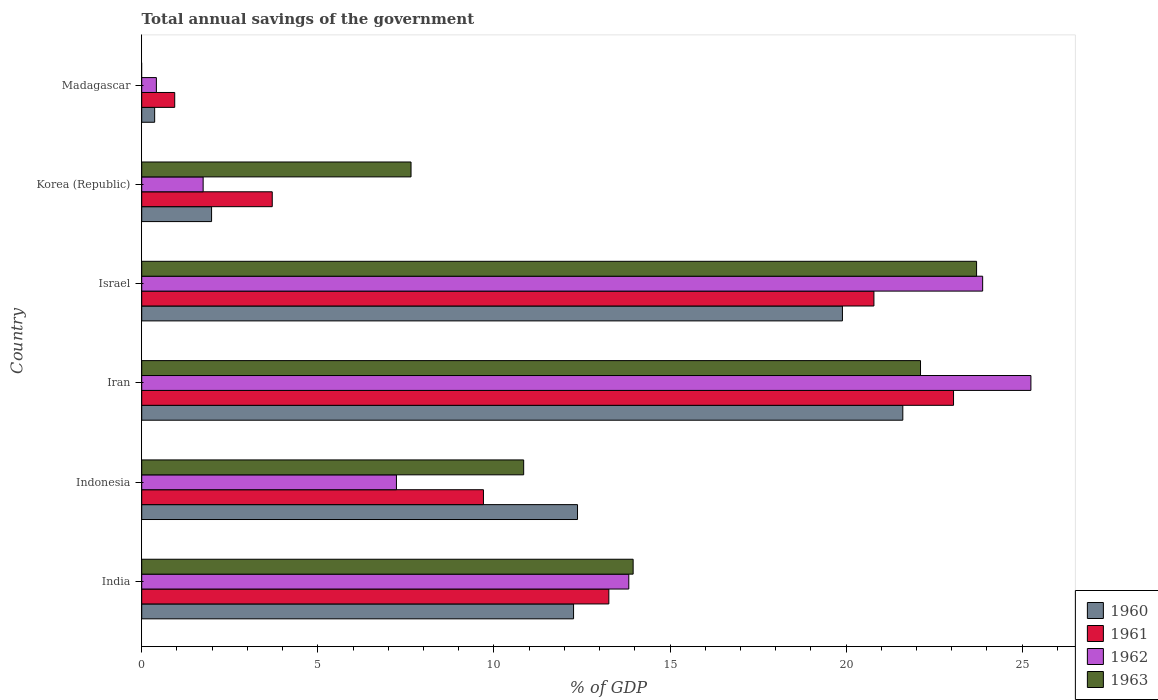How many different coloured bars are there?
Offer a very short reply. 4. How many groups of bars are there?
Your answer should be very brief. 6. Are the number of bars per tick equal to the number of legend labels?
Your answer should be very brief. No. Are the number of bars on each tick of the Y-axis equal?
Give a very brief answer. No. In how many cases, is the number of bars for a given country not equal to the number of legend labels?
Your response must be concise. 1. What is the total annual savings of the government in 1960 in Madagascar?
Make the answer very short. 0.37. Across all countries, what is the maximum total annual savings of the government in 1962?
Provide a succinct answer. 25.25. Across all countries, what is the minimum total annual savings of the government in 1960?
Provide a succinct answer. 0.37. In which country was the total annual savings of the government in 1962 maximum?
Your answer should be very brief. Iran. What is the total total annual savings of the government in 1963 in the graph?
Your response must be concise. 78.26. What is the difference between the total annual savings of the government in 1961 in Indonesia and that in Iran?
Offer a terse response. -13.35. What is the difference between the total annual savings of the government in 1963 in India and the total annual savings of the government in 1960 in Indonesia?
Provide a succinct answer. 1.58. What is the average total annual savings of the government in 1961 per country?
Your answer should be very brief. 11.91. What is the difference between the total annual savings of the government in 1961 and total annual savings of the government in 1960 in India?
Keep it short and to the point. 1. In how many countries, is the total annual savings of the government in 1960 greater than 12 %?
Provide a succinct answer. 4. What is the ratio of the total annual savings of the government in 1961 in India to that in Israel?
Provide a succinct answer. 0.64. What is the difference between the highest and the second highest total annual savings of the government in 1961?
Make the answer very short. 2.26. What is the difference between the highest and the lowest total annual savings of the government in 1962?
Your response must be concise. 24.83. Is it the case that in every country, the sum of the total annual savings of the government in 1961 and total annual savings of the government in 1962 is greater than the sum of total annual savings of the government in 1960 and total annual savings of the government in 1963?
Your answer should be compact. No. How many bars are there?
Keep it short and to the point. 23. How many countries are there in the graph?
Offer a terse response. 6. Are the values on the major ticks of X-axis written in scientific E-notation?
Offer a very short reply. No. How many legend labels are there?
Your answer should be very brief. 4. How are the legend labels stacked?
Make the answer very short. Vertical. What is the title of the graph?
Your answer should be very brief. Total annual savings of the government. Does "1981" appear as one of the legend labels in the graph?
Ensure brevity in your answer.  No. What is the label or title of the X-axis?
Ensure brevity in your answer.  % of GDP. What is the label or title of the Y-axis?
Your response must be concise. Country. What is the % of GDP in 1960 in India?
Your response must be concise. 12.26. What is the % of GDP in 1961 in India?
Your answer should be compact. 13.26. What is the % of GDP of 1962 in India?
Give a very brief answer. 13.83. What is the % of GDP of 1963 in India?
Provide a short and direct response. 13.95. What is the % of GDP of 1960 in Indonesia?
Your answer should be compact. 12.37. What is the % of GDP of 1961 in Indonesia?
Ensure brevity in your answer.  9.7. What is the % of GDP in 1962 in Indonesia?
Your answer should be very brief. 7.23. What is the % of GDP of 1963 in Indonesia?
Your answer should be compact. 10.85. What is the % of GDP in 1960 in Iran?
Keep it short and to the point. 21.61. What is the % of GDP of 1961 in Iran?
Make the answer very short. 23.05. What is the % of GDP of 1962 in Iran?
Offer a very short reply. 25.25. What is the % of GDP of 1963 in Iran?
Ensure brevity in your answer.  22.11. What is the % of GDP of 1960 in Israel?
Provide a short and direct response. 19.9. What is the % of GDP in 1961 in Israel?
Provide a short and direct response. 20.79. What is the % of GDP in 1962 in Israel?
Ensure brevity in your answer.  23.88. What is the % of GDP of 1963 in Israel?
Offer a terse response. 23.71. What is the % of GDP of 1960 in Korea (Republic)?
Provide a short and direct response. 1.98. What is the % of GDP in 1961 in Korea (Republic)?
Provide a short and direct response. 3.71. What is the % of GDP in 1962 in Korea (Republic)?
Provide a succinct answer. 1.74. What is the % of GDP of 1963 in Korea (Republic)?
Give a very brief answer. 7.65. What is the % of GDP of 1960 in Madagascar?
Provide a short and direct response. 0.37. What is the % of GDP in 1961 in Madagascar?
Your answer should be very brief. 0.94. What is the % of GDP of 1962 in Madagascar?
Ensure brevity in your answer.  0.42. Across all countries, what is the maximum % of GDP in 1960?
Offer a terse response. 21.61. Across all countries, what is the maximum % of GDP in 1961?
Your answer should be very brief. 23.05. Across all countries, what is the maximum % of GDP in 1962?
Your answer should be compact. 25.25. Across all countries, what is the maximum % of GDP of 1963?
Provide a short and direct response. 23.71. Across all countries, what is the minimum % of GDP of 1960?
Provide a short and direct response. 0.37. Across all countries, what is the minimum % of GDP in 1961?
Keep it short and to the point. 0.94. Across all countries, what is the minimum % of GDP in 1962?
Provide a succinct answer. 0.42. Across all countries, what is the minimum % of GDP of 1963?
Give a very brief answer. 0. What is the total % of GDP in 1960 in the graph?
Your answer should be very brief. 68.49. What is the total % of GDP of 1961 in the graph?
Provide a succinct answer. 71.45. What is the total % of GDP of 1962 in the graph?
Give a very brief answer. 72.35. What is the total % of GDP of 1963 in the graph?
Ensure brevity in your answer.  78.26. What is the difference between the % of GDP of 1960 in India and that in Indonesia?
Give a very brief answer. -0.11. What is the difference between the % of GDP of 1961 in India and that in Indonesia?
Your answer should be compact. 3.56. What is the difference between the % of GDP of 1962 in India and that in Indonesia?
Make the answer very short. 6.6. What is the difference between the % of GDP in 1963 in India and that in Indonesia?
Ensure brevity in your answer.  3.11. What is the difference between the % of GDP of 1960 in India and that in Iran?
Offer a very short reply. -9.35. What is the difference between the % of GDP in 1961 in India and that in Iran?
Your response must be concise. -9.79. What is the difference between the % of GDP in 1962 in India and that in Iran?
Provide a succinct answer. -11.42. What is the difference between the % of GDP of 1963 in India and that in Iran?
Provide a short and direct response. -8.16. What is the difference between the % of GDP in 1960 in India and that in Israel?
Your response must be concise. -7.63. What is the difference between the % of GDP in 1961 in India and that in Israel?
Keep it short and to the point. -7.53. What is the difference between the % of GDP of 1962 in India and that in Israel?
Keep it short and to the point. -10.05. What is the difference between the % of GDP of 1963 in India and that in Israel?
Your answer should be compact. -9.75. What is the difference between the % of GDP of 1960 in India and that in Korea (Republic)?
Offer a terse response. 10.28. What is the difference between the % of GDP of 1961 in India and that in Korea (Republic)?
Provide a short and direct response. 9.56. What is the difference between the % of GDP of 1962 in India and that in Korea (Republic)?
Give a very brief answer. 12.09. What is the difference between the % of GDP of 1963 in India and that in Korea (Republic)?
Provide a succinct answer. 6.31. What is the difference between the % of GDP in 1960 in India and that in Madagascar?
Keep it short and to the point. 11.89. What is the difference between the % of GDP in 1961 in India and that in Madagascar?
Your response must be concise. 12.33. What is the difference between the % of GDP of 1962 in India and that in Madagascar?
Your answer should be very brief. 13.41. What is the difference between the % of GDP of 1960 in Indonesia and that in Iran?
Ensure brevity in your answer.  -9.24. What is the difference between the % of GDP of 1961 in Indonesia and that in Iran?
Make the answer very short. -13.35. What is the difference between the % of GDP of 1962 in Indonesia and that in Iran?
Offer a very short reply. -18.02. What is the difference between the % of GDP in 1963 in Indonesia and that in Iran?
Make the answer very short. -11.27. What is the difference between the % of GDP in 1960 in Indonesia and that in Israel?
Provide a short and direct response. -7.52. What is the difference between the % of GDP in 1961 in Indonesia and that in Israel?
Your answer should be very brief. -11.09. What is the difference between the % of GDP of 1962 in Indonesia and that in Israel?
Provide a succinct answer. -16.65. What is the difference between the % of GDP of 1963 in Indonesia and that in Israel?
Your answer should be very brief. -12.86. What is the difference between the % of GDP of 1960 in Indonesia and that in Korea (Republic)?
Give a very brief answer. 10.39. What is the difference between the % of GDP of 1961 in Indonesia and that in Korea (Republic)?
Your response must be concise. 6. What is the difference between the % of GDP of 1962 in Indonesia and that in Korea (Republic)?
Give a very brief answer. 5.49. What is the difference between the % of GDP of 1963 in Indonesia and that in Korea (Republic)?
Keep it short and to the point. 3.2. What is the difference between the % of GDP in 1960 in Indonesia and that in Madagascar?
Your answer should be very brief. 12.01. What is the difference between the % of GDP in 1961 in Indonesia and that in Madagascar?
Offer a very short reply. 8.77. What is the difference between the % of GDP in 1962 in Indonesia and that in Madagascar?
Your response must be concise. 6.82. What is the difference between the % of GDP of 1960 in Iran and that in Israel?
Keep it short and to the point. 1.71. What is the difference between the % of GDP in 1961 in Iran and that in Israel?
Offer a terse response. 2.26. What is the difference between the % of GDP in 1962 in Iran and that in Israel?
Offer a very short reply. 1.37. What is the difference between the % of GDP of 1963 in Iran and that in Israel?
Give a very brief answer. -1.59. What is the difference between the % of GDP in 1960 in Iran and that in Korea (Republic)?
Provide a succinct answer. 19.63. What is the difference between the % of GDP in 1961 in Iran and that in Korea (Republic)?
Give a very brief answer. 19.34. What is the difference between the % of GDP of 1962 in Iran and that in Korea (Republic)?
Your answer should be compact. 23.5. What is the difference between the % of GDP of 1963 in Iran and that in Korea (Republic)?
Keep it short and to the point. 14.47. What is the difference between the % of GDP of 1960 in Iran and that in Madagascar?
Provide a succinct answer. 21.24. What is the difference between the % of GDP of 1961 in Iran and that in Madagascar?
Your answer should be very brief. 22.11. What is the difference between the % of GDP of 1962 in Iran and that in Madagascar?
Offer a terse response. 24.83. What is the difference between the % of GDP of 1960 in Israel and that in Korea (Republic)?
Provide a succinct answer. 17.91. What is the difference between the % of GDP in 1961 in Israel and that in Korea (Republic)?
Provide a succinct answer. 17.08. What is the difference between the % of GDP in 1962 in Israel and that in Korea (Republic)?
Offer a terse response. 22.13. What is the difference between the % of GDP in 1963 in Israel and that in Korea (Republic)?
Your answer should be compact. 16.06. What is the difference between the % of GDP in 1960 in Israel and that in Madagascar?
Make the answer very short. 19.53. What is the difference between the % of GDP of 1961 in Israel and that in Madagascar?
Make the answer very short. 19.85. What is the difference between the % of GDP in 1962 in Israel and that in Madagascar?
Offer a very short reply. 23.46. What is the difference between the % of GDP in 1960 in Korea (Republic) and that in Madagascar?
Ensure brevity in your answer.  1.62. What is the difference between the % of GDP in 1961 in Korea (Republic) and that in Madagascar?
Give a very brief answer. 2.77. What is the difference between the % of GDP of 1962 in Korea (Republic) and that in Madagascar?
Make the answer very short. 1.33. What is the difference between the % of GDP in 1960 in India and the % of GDP in 1961 in Indonesia?
Keep it short and to the point. 2.56. What is the difference between the % of GDP in 1960 in India and the % of GDP in 1962 in Indonesia?
Your answer should be very brief. 5.03. What is the difference between the % of GDP of 1960 in India and the % of GDP of 1963 in Indonesia?
Provide a succinct answer. 1.42. What is the difference between the % of GDP in 1961 in India and the % of GDP in 1962 in Indonesia?
Your answer should be compact. 6.03. What is the difference between the % of GDP of 1961 in India and the % of GDP of 1963 in Indonesia?
Ensure brevity in your answer.  2.42. What is the difference between the % of GDP in 1962 in India and the % of GDP in 1963 in Indonesia?
Provide a short and direct response. 2.98. What is the difference between the % of GDP in 1960 in India and the % of GDP in 1961 in Iran?
Give a very brief answer. -10.79. What is the difference between the % of GDP in 1960 in India and the % of GDP in 1962 in Iran?
Give a very brief answer. -12.99. What is the difference between the % of GDP in 1960 in India and the % of GDP in 1963 in Iran?
Make the answer very short. -9.85. What is the difference between the % of GDP of 1961 in India and the % of GDP of 1962 in Iran?
Your response must be concise. -11.98. What is the difference between the % of GDP in 1961 in India and the % of GDP in 1963 in Iran?
Your answer should be very brief. -8.85. What is the difference between the % of GDP of 1962 in India and the % of GDP of 1963 in Iran?
Provide a short and direct response. -8.28. What is the difference between the % of GDP of 1960 in India and the % of GDP of 1961 in Israel?
Your response must be concise. -8.53. What is the difference between the % of GDP in 1960 in India and the % of GDP in 1962 in Israel?
Provide a short and direct response. -11.62. What is the difference between the % of GDP in 1960 in India and the % of GDP in 1963 in Israel?
Ensure brevity in your answer.  -11.44. What is the difference between the % of GDP of 1961 in India and the % of GDP of 1962 in Israel?
Your answer should be very brief. -10.61. What is the difference between the % of GDP of 1961 in India and the % of GDP of 1963 in Israel?
Offer a very short reply. -10.44. What is the difference between the % of GDP of 1962 in India and the % of GDP of 1963 in Israel?
Your response must be concise. -9.87. What is the difference between the % of GDP in 1960 in India and the % of GDP in 1961 in Korea (Republic)?
Give a very brief answer. 8.56. What is the difference between the % of GDP of 1960 in India and the % of GDP of 1962 in Korea (Republic)?
Give a very brief answer. 10.52. What is the difference between the % of GDP in 1960 in India and the % of GDP in 1963 in Korea (Republic)?
Provide a succinct answer. 4.61. What is the difference between the % of GDP in 1961 in India and the % of GDP in 1962 in Korea (Republic)?
Ensure brevity in your answer.  11.52. What is the difference between the % of GDP of 1961 in India and the % of GDP of 1963 in Korea (Republic)?
Keep it short and to the point. 5.62. What is the difference between the % of GDP of 1962 in India and the % of GDP of 1963 in Korea (Republic)?
Make the answer very short. 6.18. What is the difference between the % of GDP of 1960 in India and the % of GDP of 1961 in Madagascar?
Your response must be concise. 11.32. What is the difference between the % of GDP of 1960 in India and the % of GDP of 1962 in Madagascar?
Offer a terse response. 11.85. What is the difference between the % of GDP in 1961 in India and the % of GDP in 1962 in Madagascar?
Give a very brief answer. 12.85. What is the difference between the % of GDP in 1960 in Indonesia and the % of GDP in 1961 in Iran?
Give a very brief answer. -10.68. What is the difference between the % of GDP in 1960 in Indonesia and the % of GDP in 1962 in Iran?
Your response must be concise. -12.87. What is the difference between the % of GDP of 1960 in Indonesia and the % of GDP of 1963 in Iran?
Provide a succinct answer. -9.74. What is the difference between the % of GDP in 1961 in Indonesia and the % of GDP in 1962 in Iran?
Keep it short and to the point. -15.54. What is the difference between the % of GDP of 1961 in Indonesia and the % of GDP of 1963 in Iran?
Offer a terse response. -12.41. What is the difference between the % of GDP in 1962 in Indonesia and the % of GDP in 1963 in Iran?
Your response must be concise. -14.88. What is the difference between the % of GDP of 1960 in Indonesia and the % of GDP of 1961 in Israel?
Offer a terse response. -8.42. What is the difference between the % of GDP in 1960 in Indonesia and the % of GDP in 1962 in Israel?
Your answer should be very brief. -11.5. What is the difference between the % of GDP in 1960 in Indonesia and the % of GDP in 1963 in Israel?
Offer a very short reply. -11.33. What is the difference between the % of GDP of 1961 in Indonesia and the % of GDP of 1962 in Israel?
Ensure brevity in your answer.  -14.17. What is the difference between the % of GDP of 1961 in Indonesia and the % of GDP of 1963 in Israel?
Ensure brevity in your answer.  -14. What is the difference between the % of GDP in 1962 in Indonesia and the % of GDP in 1963 in Israel?
Keep it short and to the point. -16.47. What is the difference between the % of GDP of 1960 in Indonesia and the % of GDP of 1961 in Korea (Republic)?
Provide a short and direct response. 8.67. What is the difference between the % of GDP of 1960 in Indonesia and the % of GDP of 1962 in Korea (Republic)?
Offer a terse response. 10.63. What is the difference between the % of GDP in 1960 in Indonesia and the % of GDP in 1963 in Korea (Republic)?
Ensure brevity in your answer.  4.73. What is the difference between the % of GDP of 1961 in Indonesia and the % of GDP of 1962 in Korea (Republic)?
Keep it short and to the point. 7.96. What is the difference between the % of GDP in 1961 in Indonesia and the % of GDP in 1963 in Korea (Republic)?
Ensure brevity in your answer.  2.06. What is the difference between the % of GDP of 1962 in Indonesia and the % of GDP of 1963 in Korea (Republic)?
Provide a succinct answer. -0.41. What is the difference between the % of GDP of 1960 in Indonesia and the % of GDP of 1961 in Madagascar?
Give a very brief answer. 11.44. What is the difference between the % of GDP of 1960 in Indonesia and the % of GDP of 1962 in Madagascar?
Keep it short and to the point. 11.96. What is the difference between the % of GDP of 1961 in Indonesia and the % of GDP of 1962 in Madagascar?
Provide a short and direct response. 9.29. What is the difference between the % of GDP of 1960 in Iran and the % of GDP of 1961 in Israel?
Give a very brief answer. 0.82. What is the difference between the % of GDP of 1960 in Iran and the % of GDP of 1962 in Israel?
Make the answer very short. -2.27. What is the difference between the % of GDP of 1960 in Iran and the % of GDP of 1963 in Israel?
Keep it short and to the point. -2.09. What is the difference between the % of GDP of 1961 in Iran and the % of GDP of 1962 in Israel?
Provide a short and direct response. -0.83. What is the difference between the % of GDP of 1961 in Iran and the % of GDP of 1963 in Israel?
Keep it short and to the point. -0.65. What is the difference between the % of GDP of 1962 in Iran and the % of GDP of 1963 in Israel?
Provide a short and direct response. 1.54. What is the difference between the % of GDP of 1960 in Iran and the % of GDP of 1961 in Korea (Republic)?
Keep it short and to the point. 17.9. What is the difference between the % of GDP in 1960 in Iran and the % of GDP in 1962 in Korea (Republic)?
Make the answer very short. 19.87. What is the difference between the % of GDP in 1960 in Iran and the % of GDP in 1963 in Korea (Republic)?
Offer a terse response. 13.96. What is the difference between the % of GDP in 1961 in Iran and the % of GDP in 1962 in Korea (Republic)?
Provide a succinct answer. 21.31. What is the difference between the % of GDP in 1961 in Iran and the % of GDP in 1963 in Korea (Republic)?
Your response must be concise. 15.4. What is the difference between the % of GDP in 1962 in Iran and the % of GDP in 1963 in Korea (Republic)?
Make the answer very short. 17.6. What is the difference between the % of GDP of 1960 in Iran and the % of GDP of 1961 in Madagascar?
Offer a very short reply. 20.67. What is the difference between the % of GDP in 1960 in Iran and the % of GDP in 1962 in Madagascar?
Your answer should be compact. 21.19. What is the difference between the % of GDP of 1961 in Iran and the % of GDP of 1962 in Madagascar?
Offer a very short reply. 22.63. What is the difference between the % of GDP in 1960 in Israel and the % of GDP in 1961 in Korea (Republic)?
Ensure brevity in your answer.  16.19. What is the difference between the % of GDP of 1960 in Israel and the % of GDP of 1962 in Korea (Republic)?
Your answer should be compact. 18.15. What is the difference between the % of GDP of 1960 in Israel and the % of GDP of 1963 in Korea (Republic)?
Your response must be concise. 12.25. What is the difference between the % of GDP of 1961 in Israel and the % of GDP of 1962 in Korea (Republic)?
Provide a short and direct response. 19.05. What is the difference between the % of GDP in 1961 in Israel and the % of GDP in 1963 in Korea (Republic)?
Offer a terse response. 13.14. What is the difference between the % of GDP in 1962 in Israel and the % of GDP in 1963 in Korea (Republic)?
Provide a succinct answer. 16.23. What is the difference between the % of GDP of 1960 in Israel and the % of GDP of 1961 in Madagascar?
Make the answer very short. 18.96. What is the difference between the % of GDP in 1960 in Israel and the % of GDP in 1962 in Madagascar?
Your answer should be compact. 19.48. What is the difference between the % of GDP in 1961 in Israel and the % of GDP in 1962 in Madagascar?
Your response must be concise. 20.37. What is the difference between the % of GDP of 1960 in Korea (Republic) and the % of GDP of 1961 in Madagascar?
Your response must be concise. 1.05. What is the difference between the % of GDP of 1960 in Korea (Republic) and the % of GDP of 1962 in Madagascar?
Your answer should be very brief. 1.57. What is the difference between the % of GDP in 1961 in Korea (Republic) and the % of GDP in 1962 in Madagascar?
Your answer should be very brief. 3.29. What is the average % of GDP of 1960 per country?
Keep it short and to the point. 11.42. What is the average % of GDP in 1961 per country?
Provide a short and direct response. 11.91. What is the average % of GDP in 1962 per country?
Provide a succinct answer. 12.06. What is the average % of GDP in 1963 per country?
Ensure brevity in your answer.  13.04. What is the difference between the % of GDP in 1960 and % of GDP in 1961 in India?
Your answer should be very brief. -1. What is the difference between the % of GDP in 1960 and % of GDP in 1962 in India?
Give a very brief answer. -1.57. What is the difference between the % of GDP in 1960 and % of GDP in 1963 in India?
Your answer should be compact. -1.69. What is the difference between the % of GDP in 1961 and % of GDP in 1962 in India?
Make the answer very short. -0.57. What is the difference between the % of GDP of 1961 and % of GDP of 1963 in India?
Offer a very short reply. -0.69. What is the difference between the % of GDP of 1962 and % of GDP of 1963 in India?
Make the answer very short. -0.12. What is the difference between the % of GDP in 1960 and % of GDP in 1961 in Indonesia?
Offer a very short reply. 2.67. What is the difference between the % of GDP in 1960 and % of GDP in 1962 in Indonesia?
Offer a very short reply. 5.14. What is the difference between the % of GDP of 1960 and % of GDP of 1963 in Indonesia?
Offer a terse response. 1.53. What is the difference between the % of GDP in 1961 and % of GDP in 1962 in Indonesia?
Ensure brevity in your answer.  2.47. What is the difference between the % of GDP of 1961 and % of GDP of 1963 in Indonesia?
Provide a short and direct response. -1.14. What is the difference between the % of GDP in 1962 and % of GDP in 1963 in Indonesia?
Provide a short and direct response. -3.61. What is the difference between the % of GDP of 1960 and % of GDP of 1961 in Iran?
Provide a short and direct response. -1.44. What is the difference between the % of GDP in 1960 and % of GDP in 1962 in Iran?
Provide a succinct answer. -3.64. What is the difference between the % of GDP of 1960 and % of GDP of 1963 in Iran?
Offer a terse response. -0.5. What is the difference between the % of GDP in 1961 and % of GDP in 1962 in Iran?
Provide a short and direct response. -2.2. What is the difference between the % of GDP of 1961 and % of GDP of 1963 in Iran?
Provide a short and direct response. 0.94. What is the difference between the % of GDP in 1962 and % of GDP in 1963 in Iran?
Your answer should be compact. 3.13. What is the difference between the % of GDP of 1960 and % of GDP of 1961 in Israel?
Provide a short and direct response. -0.89. What is the difference between the % of GDP of 1960 and % of GDP of 1962 in Israel?
Make the answer very short. -3.98. What is the difference between the % of GDP of 1960 and % of GDP of 1963 in Israel?
Give a very brief answer. -3.81. What is the difference between the % of GDP of 1961 and % of GDP of 1962 in Israel?
Provide a short and direct response. -3.09. What is the difference between the % of GDP of 1961 and % of GDP of 1963 in Israel?
Make the answer very short. -2.91. What is the difference between the % of GDP in 1962 and % of GDP in 1963 in Israel?
Ensure brevity in your answer.  0.17. What is the difference between the % of GDP of 1960 and % of GDP of 1961 in Korea (Republic)?
Your answer should be compact. -1.72. What is the difference between the % of GDP of 1960 and % of GDP of 1962 in Korea (Republic)?
Your answer should be very brief. 0.24. What is the difference between the % of GDP in 1960 and % of GDP in 1963 in Korea (Republic)?
Your response must be concise. -5.66. What is the difference between the % of GDP of 1961 and % of GDP of 1962 in Korea (Republic)?
Your answer should be very brief. 1.96. What is the difference between the % of GDP in 1961 and % of GDP in 1963 in Korea (Republic)?
Ensure brevity in your answer.  -3.94. What is the difference between the % of GDP of 1962 and % of GDP of 1963 in Korea (Republic)?
Keep it short and to the point. -5.9. What is the difference between the % of GDP in 1960 and % of GDP in 1961 in Madagascar?
Provide a succinct answer. -0.57. What is the difference between the % of GDP in 1960 and % of GDP in 1962 in Madagascar?
Give a very brief answer. -0.05. What is the difference between the % of GDP of 1961 and % of GDP of 1962 in Madagascar?
Your response must be concise. 0.52. What is the ratio of the % of GDP in 1960 in India to that in Indonesia?
Give a very brief answer. 0.99. What is the ratio of the % of GDP of 1961 in India to that in Indonesia?
Provide a succinct answer. 1.37. What is the ratio of the % of GDP in 1962 in India to that in Indonesia?
Your answer should be very brief. 1.91. What is the ratio of the % of GDP of 1963 in India to that in Indonesia?
Offer a very short reply. 1.29. What is the ratio of the % of GDP of 1960 in India to that in Iran?
Your response must be concise. 0.57. What is the ratio of the % of GDP of 1961 in India to that in Iran?
Give a very brief answer. 0.58. What is the ratio of the % of GDP in 1962 in India to that in Iran?
Provide a short and direct response. 0.55. What is the ratio of the % of GDP of 1963 in India to that in Iran?
Provide a succinct answer. 0.63. What is the ratio of the % of GDP of 1960 in India to that in Israel?
Give a very brief answer. 0.62. What is the ratio of the % of GDP in 1961 in India to that in Israel?
Your answer should be very brief. 0.64. What is the ratio of the % of GDP of 1962 in India to that in Israel?
Your answer should be very brief. 0.58. What is the ratio of the % of GDP of 1963 in India to that in Israel?
Make the answer very short. 0.59. What is the ratio of the % of GDP of 1960 in India to that in Korea (Republic)?
Your answer should be compact. 6.18. What is the ratio of the % of GDP in 1961 in India to that in Korea (Republic)?
Give a very brief answer. 3.58. What is the ratio of the % of GDP of 1962 in India to that in Korea (Republic)?
Give a very brief answer. 7.93. What is the ratio of the % of GDP of 1963 in India to that in Korea (Republic)?
Provide a succinct answer. 1.82. What is the ratio of the % of GDP in 1960 in India to that in Madagascar?
Make the answer very short. 33.41. What is the ratio of the % of GDP in 1961 in India to that in Madagascar?
Your response must be concise. 14.16. What is the ratio of the % of GDP of 1962 in India to that in Madagascar?
Provide a short and direct response. 33.25. What is the ratio of the % of GDP of 1960 in Indonesia to that in Iran?
Ensure brevity in your answer.  0.57. What is the ratio of the % of GDP of 1961 in Indonesia to that in Iran?
Provide a short and direct response. 0.42. What is the ratio of the % of GDP in 1962 in Indonesia to that in Iran?
Your answer should be very brief. 0.29. What is the ratio of the % of GDP of 1963 in Indonesia to that in Iran?
Keep it short and to the point. 0.49. What is the ratio of the % of GDP in 1960 in Indonesia to that in Israel?
Your response must be concise. 0.62. What is the ratio of the % of GDP of 1961 in Indonesia to that in Israel?
Offer a very short reply. 0.47. What is the ratio of the % of GDP in 1962 in Indonesia to that in Israel?
Keep it short and to the point. 0.3. What is the ratio of the % of GDP of 1963 in Indonesia to that in Israel?
Your answer should be very brief. 0.46. What is the ratio of the % of GDP in 1960 in Indonesia to that in Korea (Republic)?
Ensure brevity in your answer.  6.24. What is the ratio of the % of GDP in 1961 in Indonesia to that in Korea (Republic)?
Provide a short and direct response. 2.62. What is the ratio of the % of GDP in 1962 in Indonesia to that in Korea (Republic)?
Keep it short and to the point. 4.15. What is the ratio of the % of GDP of 1963 in Indonesia to that in Korea (Republic)?
Keep it short and to the point. 1.42. What is the ratio of the % of GDP of 1960 in Indonesia to that in Madagascar?
Offer a terse response. 33.71. What is the ratio of the % of GDP of 1961 in Indonesia to that in Madagascar?
Your answer should be compact. 10.36. What is the ratio of the % of GDP in 1962 in Indonesia to that in Madagascar?
Offer a very short reply. 17.39. What is the ratio of the % of GDP of 1960 in Iran to that in Israel?
Provide a succinct answer. 1.09. What is the ratio of the % of GDP of 1961 in Iran to that in Israel?
Make the answer very short. 1.11. What is the ratio of the % of GDP in 1962 in Iran to that in Israel?
Ensure brevity in your answer.  1.06. What is the ratio of the % of GDP in 1963 in Iran to that in Israel?
Provide a short and direct response. 0.93. What is the ratio of the % of GDP in 1960 in Iran to that in Korea (Republic)?
Provide a succinct answer. 10.89. What is the ratio of the % of GDP in 1961 in Iran to that in Korea (Republic)?
Offer a terse response. 6.22. What is the ratio of the % of GDP of 1962 in Iran to that in Korea (Republic)?
Your answer should be compact. 14.48. What is the ratio of the % of GDP in 1963 in Iran to that in Korea (Republic)?
Ensure brevity in your answer.  2.89. What is the ratio of the % of GDP of 1960 in Iran to that in Madagascar?
Your answer should be very brief. 58.88. What is the ratio of the % of GDP in 1961 in Iran to that in Madagascar?
Make the answer very short. 24.6. What is the ratio of the % of GDP in 1962 in Iran to that in Madagascar?
Your response must be concise. 60.69. What is the ratio of the % of GDP in 1960 in Israel to that in Korea (Republic)?
Your answer should be very brief. 10.03. What is the ratio of the % of GDP in 1961 in Israel to that in Korea (Republic)?
Provide a succinct answer. 5.61. What is the ratio of the % of GDP in 1962 in Israel to that in Korea (Republic)?
Give a very brief answer. 13.69. What is the ratio of the % of GDP of 1963 in Israel to that in Korea (Republic)?
Provide a short and direct response. 3.1. What is the ratio of the % of GDP of 1960 in Israel to that in Madagascar?
Your response must be concise. 54.21. What is the ratio of the % of GDP of 1961 in Israel to that in Madagascar?
Ensure brevity in your answer.  22.19. What is the ratio of the % of GDP of 1962 in Israel to that in Madagascar?
Provide a short and direct response. 57.4. What is the ratio of the % of GDP of 1960 in Korea (Republic) to that in Madagascar?
Give a very brief answer. 5.4. What is the ratio of the % of GDP in 1961 in Korea (Republic) to that in Madagascar?
Keep it short and to the point. 3.96. What is the ratio of the % of GDP of 1962 in Korea (Republic) to that in Madagascar?
Make the answer very short. 4.19. What is the difference between the highest and the second highest % of GDP of 1960?
Make the answer very short. 1.71. What is the difference between the highest and the second highest % of GDP in 1961?
Your answer should be compact. 2.26. What is the difference between the highest and the second highest % of GDP in 1962?
Ensure brevity in your answer.  1.37. What is the difference between the highest and the second highest % of GDP in 1963?
Offer a very short reply. 1.59. What is the difference between the highest and the lowest % of GDP in 1960?
Offer a very short reply. 21.24. What is the difference between the highest and the lowest % of GDP in 1961?
Provide a short and direct response. 22.11. What is the difference between the highest and the lowest % of GDP in 1962?
Your answer should be very brief. 24.83. What is the difference between the highest and the lowest % of GDP in 1963?
Your answer should be very brief. 23.7. 